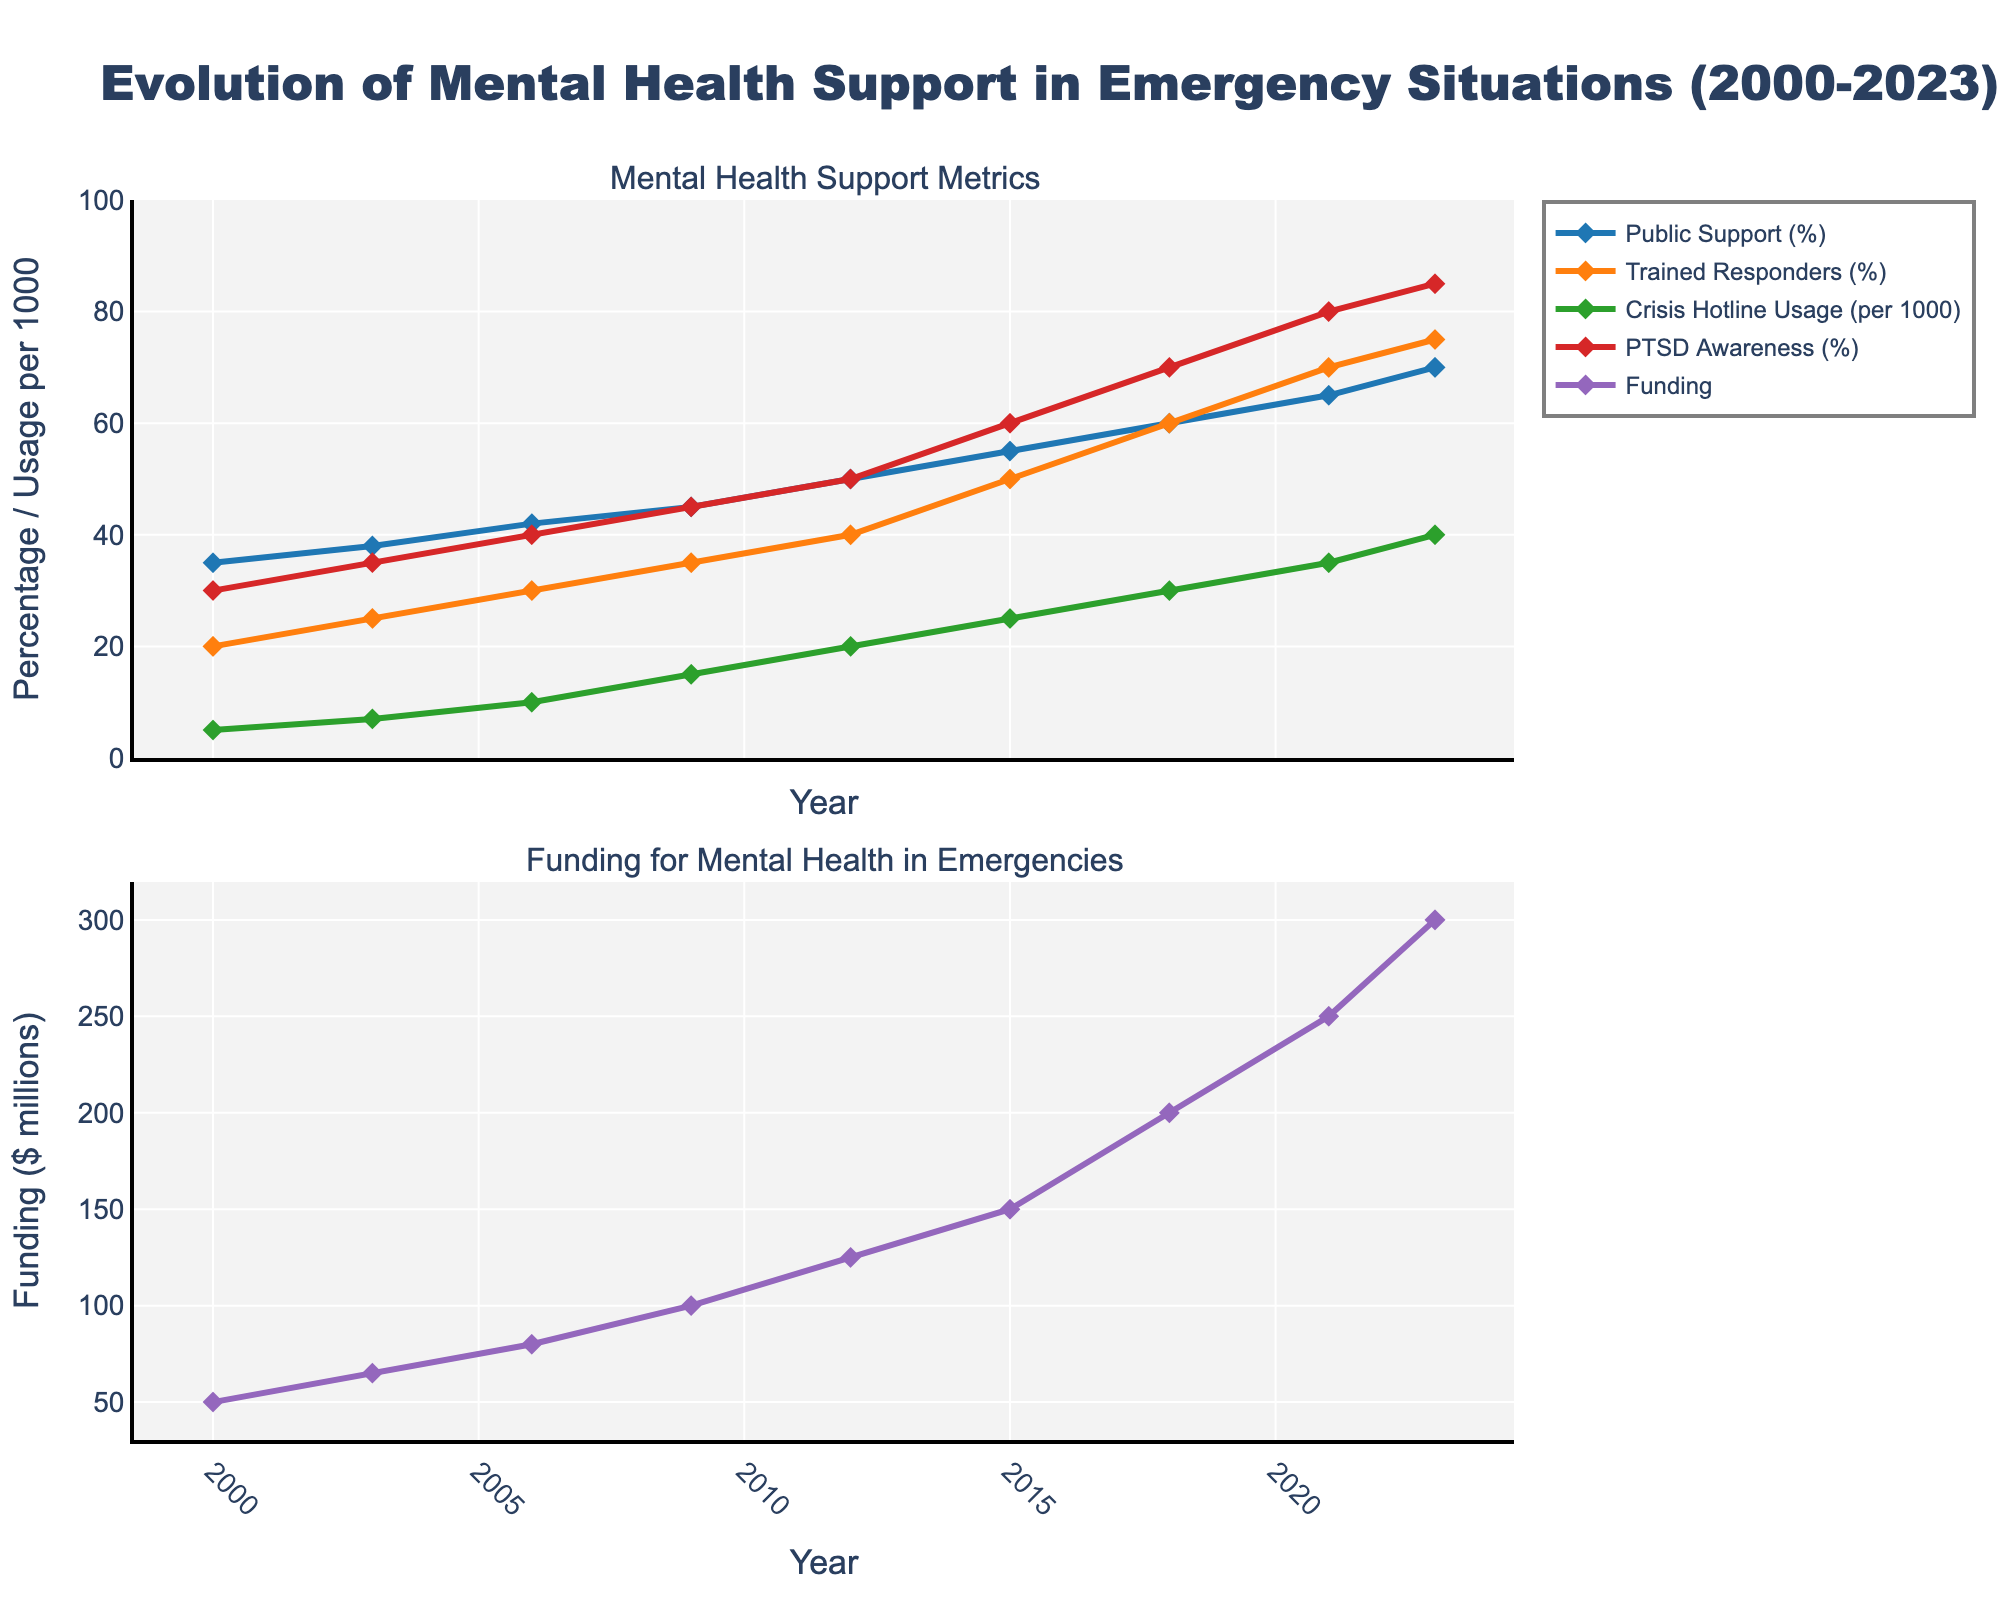What's the average percentage of Public Support (%) in 2000 and 2023? The percentage of Public Support in 2000 is 35% and in 2023 is 70%. The average is calculated as (35 + 70) / 2 = 52.5.
Answer: 52.5 How much more was the Funding for Mental Health in Emergencies in 2023 compared to 2000? The funding in 2020 was $50 million and in 2023 it was $300 million. The increase is $300M - $50M = $250M.
Answer: $250 million Which year had the highest PTSD Awareness (%)? By scanning the PTSD Awareness (%) line, the highest value is in 2023 at 85%.
Answer: 2023 In which years was the Crisis Hotline Usage (per 1000) greater than 20? Crisis Hotline Usage is greater than 20 in the years 2012, 2015, 2018, 2021, and 2023.
Answer: 2012, 2015, 2018, 2021, 2023 Compare the number of Trained Responders (%) between 2006 and 2023. Was it higher in 2023 and by how much? In 2006, Trained Responders were at 30%, and in 2023 they were at 75%. The difference is 75% - 30% = 45%.
Answer: Higher by 45% Which metric shows the most significant increase from 2000 to 2023? By analyzing the slopes of all lines from 2000 to 2023, Funding for Mental Health in Emergencies shows the most significant increase from $50 million to $300 million.
Answer: Funding for Mental Health in Emergencies How did the Public Support (%) change from 2003 to 2006? Public Support (%) increased from 38% in 2003 to 42% in 2006. The change is 42% - 38% = 4%.
Answer: Increased by 4% Is the Crisis Hotline Usage (per 1000) line in the first or second subplot? The Crisis Hotline Usage (per 1000) line is shown in the first subplot.
Answer: First subplot How many percentage points did PTSD Awareness (%) increase from 2015 to 2021? PTSD Awareness increased from 60% in 2015 to 80% in 2021. The increase is 80% - 60% = 20 percentage points.
Answer: 20 percentage points What color is used for the line representing Trained Responders (%)? Scanning the chart, the line representing Trained Responders (%) is colored orange.
Answer: Orange 